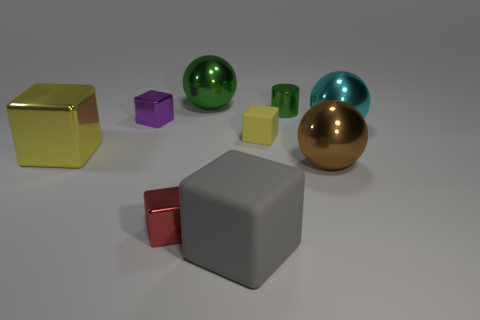Subtract all yellow rubber cubes. How many cubes are left? 4 Subtract all purple cubes. How many cubes are left? 4 Subtract all blue cubes. Subtract all blue cylinders. How many cubes are left? 5 Add 1 big green shiny spheres. How many objects exist? 10 Subtract all blocks. How many objects are left? 4 Subtract all brown matte cylinders. Subtract all small green metallic things. How many objects are left? 8 Add 2 yellow rubber blocks. How many yellow rubber blocks are left? 3 Add 6 yellow cylinders. How many yellow cylinders exist? 6 Subtract 0 brown cylinders. How many objects are left? 9 